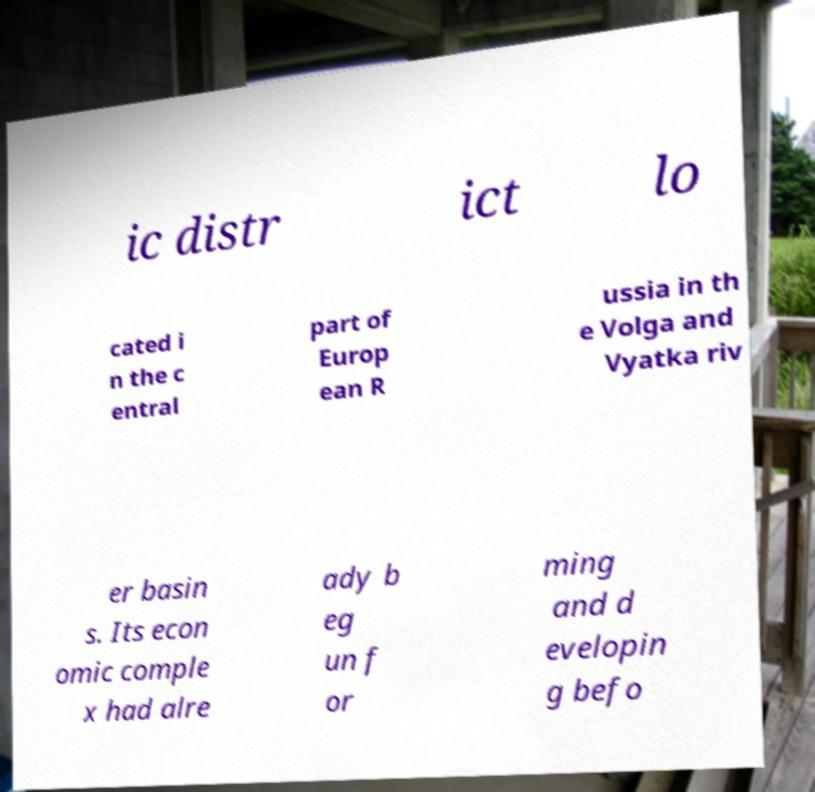There's text embedded in this image that I need extracted. Can you transcribe it verbatim? ic distr ict lo cated i n the c entral part of Europ ean R ussia in th e Volga and Vyatka riv er basin s. Its econ omic comple x had alre ady b eg un f or ming and d evelopin g befo 